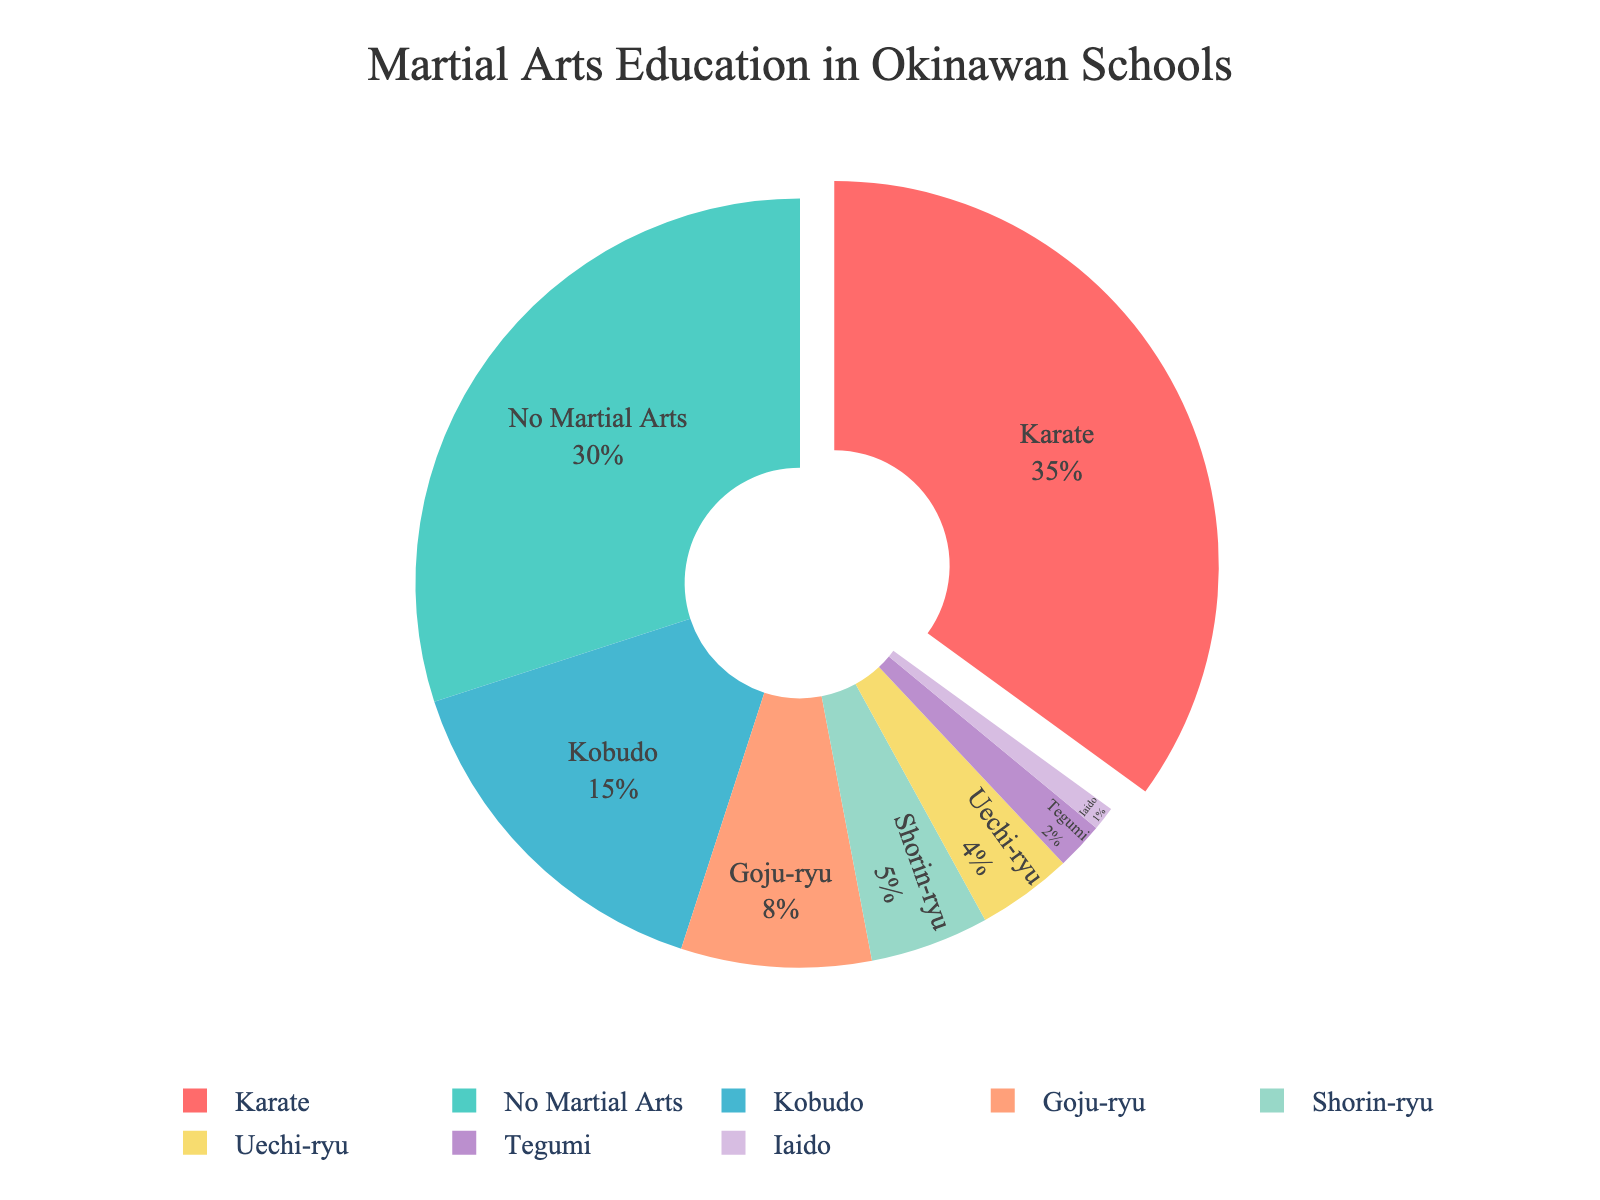What percentage of Okinawan schools include Karate in their curriculum? The chart shows the percentage values for each martial arts education type. According to the figure, Karate is indicated at 35%.
Answer: 35% Which martial arts education type is the least incorporated in Okinawan schools? By looking at the smallest slice in the pie chart, Iaido appears to have the least percentage among all listed types.
Answer: Iaido How much greater is the percentage of schools incorporating Goju-ryu compared to Iaido? The percentage for Goju-ryu is 8% and for Iaido is 1%. The difference in their values can be calculated as 8% - 1% = 7%.
Answer: 7% What is the combined percentage of schools incorporating Goju-ryu and Shorin-ryu? According to the chart, Goju-ryu accounts for 8% and Shorin-ryu for 5%. Adding these two percentages gives us 8% + 5% = 13%.
Answer: 13% Which color represents Kobudo in the pie chart? The colors in the chart are matched with the descriptive labels. According to the order and color palette, Kobudo is represented by the third color, which is turquoise or a close variant (as detailed in the custom colors).
Answer: Turquoise How much less is the percentage of schools including Uechi-ryu compared to Karate? The percentage of schools incorporating Uechi-ryu is 4%, and for Karate, it is 35%. Therefore, the difference is 35% - 4% = 31%.
Answer: 31% How much of the pie chart is accounted for by martial arts other than Karate and "No Martial Arts"? The given percentages for Karate and No Martial Arts sum up to 35% + 30% = 65%. Therefore, martial arts other than these account for 100% - 65% = 35%.
Answer: 35% What is the difference between the percentages of schools incorporating Kobudo and Tegumi? According to the figure, the percentages for Kobudo and Tegumi are 15% and 2%, respectively. The difference can be calculated as 15% - 2% = 13%.
Answer: 13% 